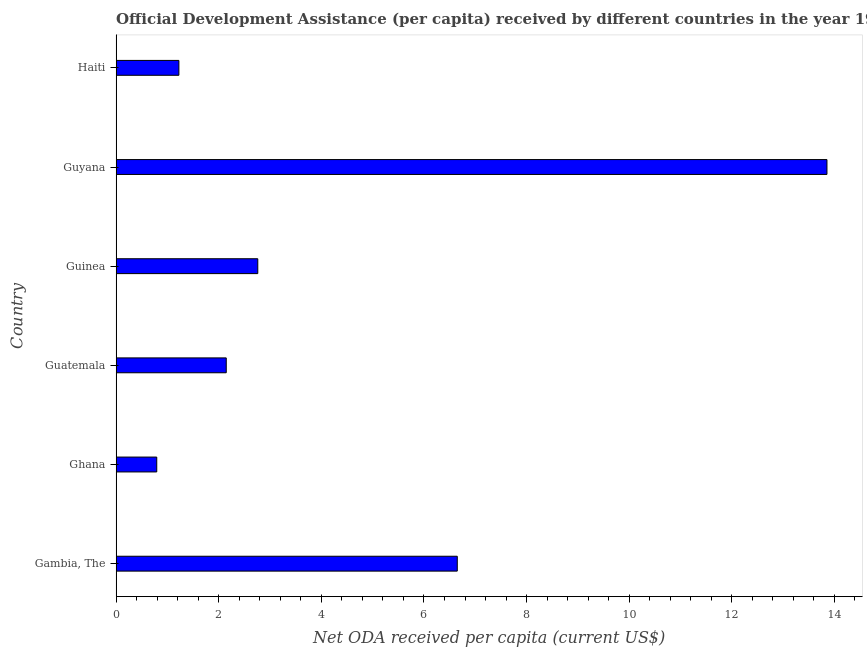What is the title of the graph?
Make the answer very short. Official Development Assistance (per capita) received by different countries in the year 1962. What is the label or title of the X-axis?
Offer a very short reply. Net ODA received per capita (current US$). What is the label or title of the Y-axis?
Keep it short and to the point. Country. What is the net oda received per capita in Haiti?
Make the answer very short. 1.22. Across all countries, what is the maximum net oda received per capita?
Ensure brevity in your answer.  13.85. Across all countries, what is the minimum net oda received per capita?
Give a very brief answer. 0.79. In which country was the net oda received per capita maximum?
Provide a succinct answer. Guyana. In which country was the net oda received per capita minimum?
Provide a succinct answer. Ghana. What is the sum of the net oda received per capita?
Make the answer very short. 27.42. What is the difference between the net oda received per capita in Gambia, The and Ghana?
Ensure brevity in your answer.  5.86. What is the average net oda received per capita per country?
Provide a succinct answer. 4.57. What is the median net oda received per capita?
Offer a terse response. 2.45. What is the ratio of the net oda received per capita in Guatemala to that in Guyana?
Your response must be concise. 0.15. What is the difference between the highest and the second highest net oda received per capita?
Ensure brevity in your answer.  7.21. Is the sum of the net oda received per capita in Ghana and Haiti greater than the maximum net oda received per capita across all countries?
Your response must be concise. No. What is the difference between the highest and the lowest net oda received per capita?
Offer a terse response. 13.06. In how many countries, is the net oda received per capita greater than the average net oda received per capita taken over all countries?
Make the answer very short. 2. How many bars are there?
Ensure brevity in your answer.  6. How many countries are there in the graph?
Your answer should be compact. 6. Are the values on the major ticks of X-axis written in scientific E-notation?
Keep it short and to the point. No. What is the Net ODA received per capita (current US$) in Gambia, The?
Give a very brief answer. 6.65. What is the Net ODA received per capita (current US$) in Ghana?
Your response must be concise. 0.79. What is the Net ODA received per capita (current US$) in Guatemala?
Offer a very short reply. 2.15. What is the Net ODA received per capita (current US$) of Guinea?
Your response must be concise. 2.76. What is the Net ODA received per capita (current US$) of Guyana?
Your response must be concise. 13.85. What is the Net ODA received per capita (current US$) of Haiti?
Your answer should be compact. 1.22. What is the difference between the Net ODA received per capita (current US$) in Gambia, The and Ghana?
Offer a terse response. 5.86. What is the difference between the Net ODA received per capita (current US$) in Gambia, The and Guatemala?
Offer a terse response. 4.5. What is the difference between the Net ODA received per capita (current US$) in Gambia, The and Guinea?
Provide a succinct answer. 3.89. What is the difference between the Net ODA received per capita (current US$) in Gambia, The and Guyana?
Provide a short and direct response. -7.2. What is the difference between the Net ODA received per capita (current US$) in Gambia, The and Haiti?
Your answer should be compact. 5.43. What is the difference between the Net ODA received per capita (current US$) in Ghana and Guatemala?
Offer a terse response. -1.35. What is the difference between the Net ODA received per capita (current US$) in Ghana and Guinea?
Your answer should be compact. -1.97. What is the difference between the Net ODA received per capita (current US$) in Ghana and Guyana?
Make the answer very short. -13.06. What is the difference between the Net ODA received per capita (current US$) in Ghana and Haiti?
Your response must be concise. -0.43. What is the difference between the Net ODA received per capita (current US$) in Guatemala and Guinea?
Offer a very short reply. -0.61. What is the difference between the Net ODA received per capita (current US$) in Guatemala and Guyana?
Offer a terse response. -11.71. What is the difference between the Net ODA received per capita (current US$) in Guatemala and Haiti?
Your response must be concise. 0.92. What is the difference between the Net ODA received per capita (current US$) in Guinea and Guyana?
Provide a short and direct response. -11.09. What is the difference between the Net ODA received per capita (current US$) in Guinea and Haiti?
Offer a terse response. 1.54. What is the difference between the Net ODA received per capita (current US$) in Guyana and Haiti?
Provide a short and direct response. 12.63. What is the ratio of the Net ODA received per capita (current US$) in Gambia, The to that in Ghana?
Make the answer very short. 8.4. What is the ratio of the Net ODA received per capita (current US$) in Gambia, The to that in Guatemala?
Your answer should be very brief. 3.1. What is the ratio of the Net ODA received per capita (current US$) in Gambia, The to that in Guinea?
Give a very brief answer. 2.41. What is the ratio of the Net ODA received per capita (current US$) in Gambia, The to that in Guyana?
Keep it short and to the point. 0.48. What is the ratio of the Net ODA received per capita (current US$) in Gambia, The to that in Haiti?
Your answer should be very brief. 5.44. What is the ratio of the Net ODA received per capita (current US$) in Ghana to that in Guatemala?
Your answer should be very brief. 0.37. What is the ratio of the Net ODA received per capita (current US$) in Ghana to that in Guinea?
Your answer should be compact. 0.29. What is the ratio of the Net ODA received per capita (current US$) in Ghana to that in Guyana?
Ensure brevity in your answer.  0.06. What is the ratio of the Net ODA received per capita (current US$) in Ghana to that in Haiti?
Provide a short and direct response. 0.65. What is the ratio of the Net ODA received per capita (current US$) in Guatemala to that in Guinea?
Provide a short and direct response. 0.78. What is the ratio of the Net ODA received per capita (current US$) in Guatemala to that in Guyana?
Your answer should be very brief. 0.15. What is the ratio of the Net ODA received per capita (current US$) in Guatemala to that in Haiti?
Keep it short and to the point. 1.75. What is the ratio of the Net ODA received per capita (current US$) in Guinea to that in Guyana?
Your answer should be compact. 0.2. What is the ratio of the Net ODA received per capita (current US$) in Guinea to that in Haiti?
Provide a succinct answer. 2.26. What is the ratio of the Net ODA received per capita (current US$) in Guyana to that in Haiti?
Ensure brevity in your answer.  11.33. 